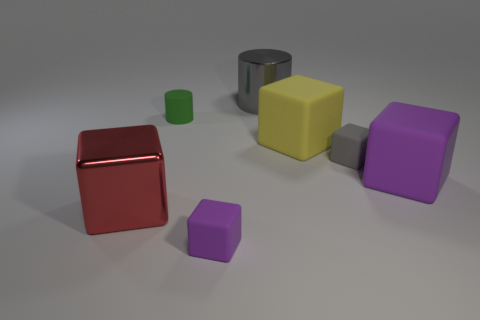Subtract all purple blocks. How many blocks are left? 3 Subtract all yellow matte blocks. How many blocks are left? 4 Subtract 1 blocks. How many blocks are left? 4 Add 1 cyan metal blocks. How many objects exist? 8 Subtract all gray blocks. Subtract all cyan cylinders. How many blocks are left? 4 Subtract all blocks. How many objects are left? 2 Subtract 0 purple cylinders. How many objects are left? 7 Subtract all small blocks. Subtract all big purple matte things. How many objects are left? 4 Add 3 tiny gray blocks. How many tiny gray blocks are left? 4 Add 5 small green rubber objects. How many small green rubber objects exist? 6 